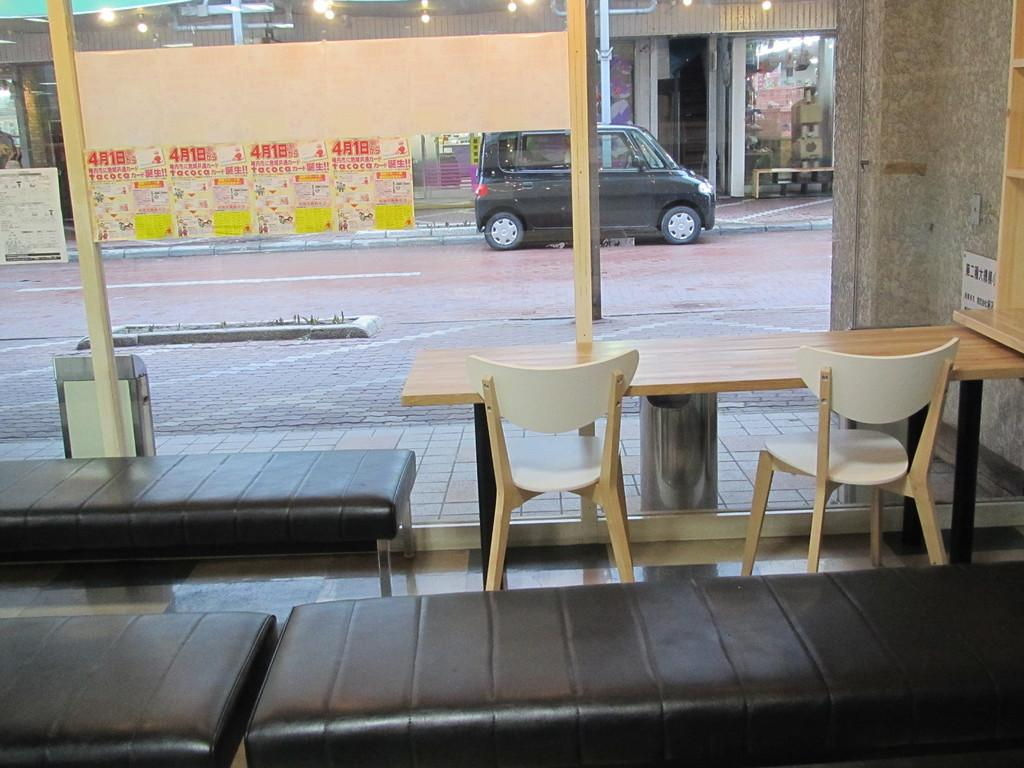What type of furniture is located in the center of the image? There are tables and chairs in the center of the image. What other type of seating can be seen in the image? There are benches in the image. What is visible in the background of the image? There is a vehicle and a shed in the background of the image. What can be seen at the top of the image? There are lights visible at the top of the image. How many oranges are being raked by the limit in the image? There are no oranges, rakes, or limits present in the image. 